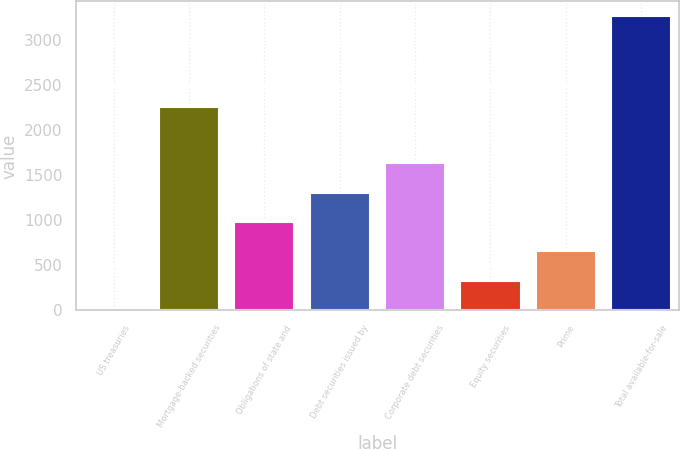<chart> <loc_0><loc_0><loc_500><loc_500><bar_chart><fcel>US treasuries<fcel>Mortgage-backed securities<fcel>Obligations of state and<fcel>Debt securities issued by<fcel>Corporate debt securities<fcel>Equity securities<fcel>Prime<fcel>Total available-for-sale<nl><fcel>2<fcel>2257<fcel>980.6<fcel>1306.8<fcel>1633<fcel>328.2<fcel>654.4<fcel>3264<nl></chart> 